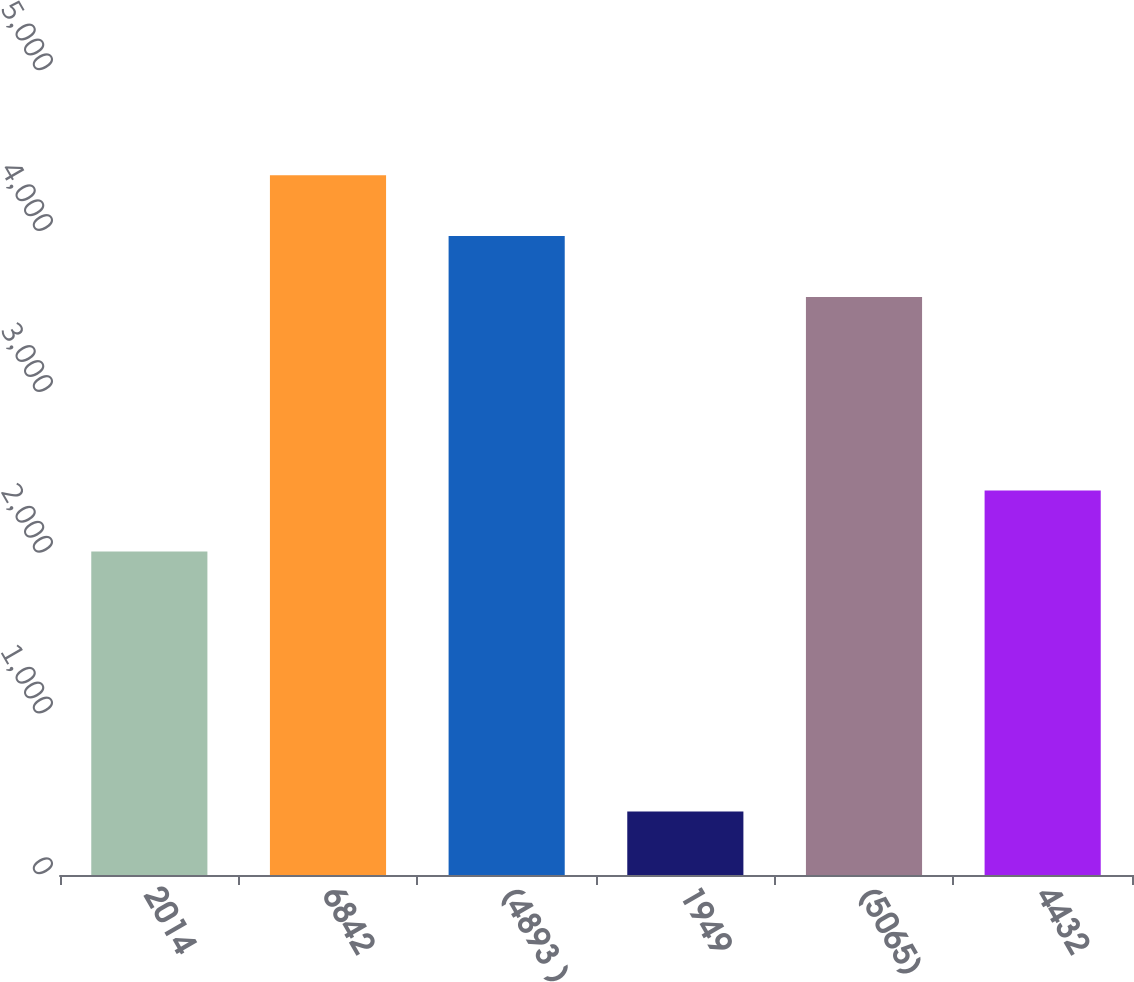Convert chart to OTSL. <chart><loc_0><loc_0><loc_500><loc_500><bar_chart><fcel>2014<fcel>6842<fcel>(4893 )<fcel>1949<fcel>(5065)<fcel>4432<nl><fcel>2012<fcel>4352<fcel>3973.5<fcel>395<fcel>3595<fcel>2390.5<nl></chart> 